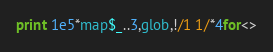Convert code to text. <code><loc_0><loc_0><loc_500><loc_500><_Perl_>print 1e5*map$_..3,glob,!/1 1/*4for<></code> 